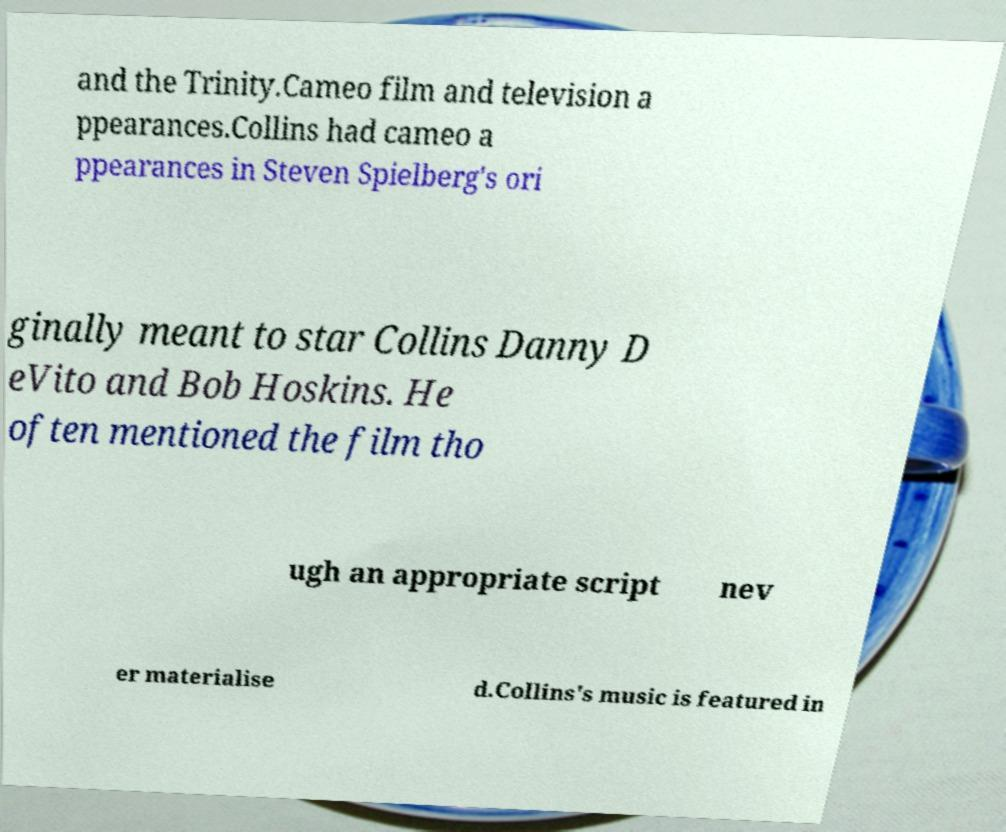I need the written content from this picture converted into text. Can you do that? and the Trinity.Cameo film and television a ppearances.Collins had cameo a ppearances in Steven Spielberg's ori ginally meant to star Collins Danny D eVito and Bob Hoskins. He often mentioned the film tho ugh an appropriate script nev er materialise d.Collins's music is featured in 